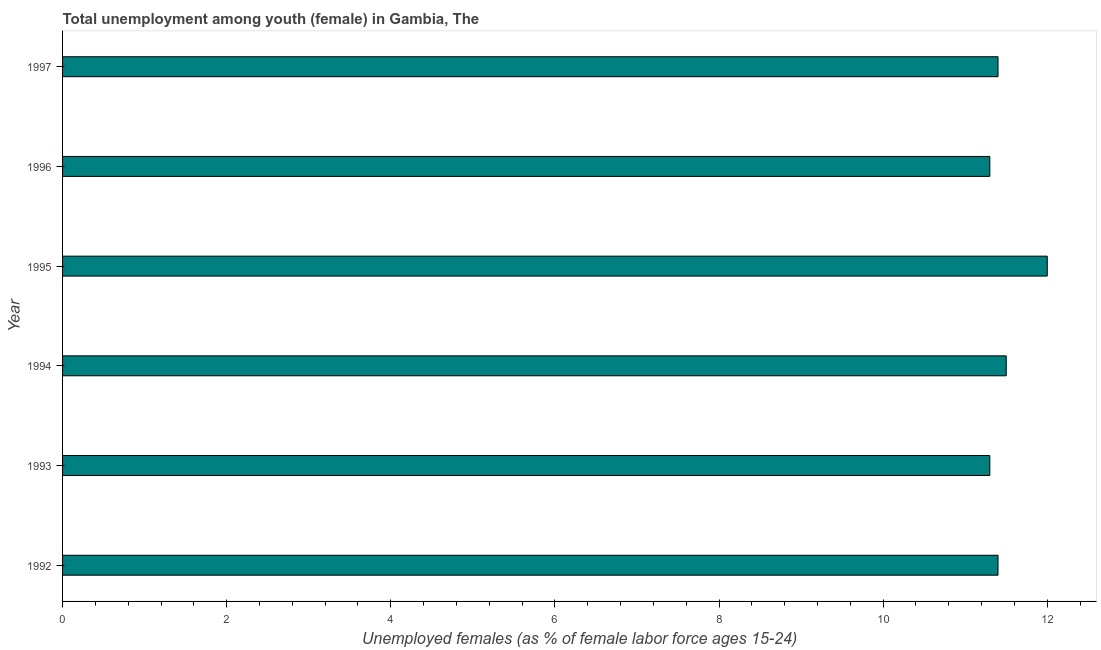Does the graph contain any zero values?
Ensure brevity in your answer.  No. What is the title of the graph?
Your response must be concise. Total unemployment among youth (female) in Gambia, The. What is the label or title of the X-axis?
Keep it short and to the point. Unemployed females (as % of female labor force ages 15-24). What is the label or title of the Y-axis?
Your answer should be compact. Year. What is the unemployed female youth population in 1997?
Your response must be concise. 11.4. Across all years, what is the maximum unemployed female youth population?
Provide a succinct answer. 12. Across all years, what is the minimum unemployed female youth population?
Provide a succinct answer. 11.3. What is the sum of the unemployed female youth population?
Offer a terse response. 68.9. What is the average unemployed female youth population per year?
Your response must be concise. 11.48. What is the median unemployed female youth population?
Your answer should be very brief. 11.4. Do a majority of the years between 1993 and 1997 (inclusive) have unemployed female youth population greater than 9.6 %?
Your answer should be compact. Yes. What is the ratio of the unemployed female youth population in 1992 to that in 1996?
Keep it short and to the point. 1.01. Is the difference between the unemployed female youth population in 1992 and 1996 greater than the difference between any two years?
Provide a short and direct response. No. Is the sum of the unemployed female youth population in 1996 and 1997 greater than the maximum unemployed female youth population across all years?
Your response must be concise. Yes. What is the difference between the highest and the lowest unemployed female youth population?
Provide a short and direct response. 0.7. How many bars are there?
Give a very brief answer. 6. What is the difference between two consecutive major ticks on the X-axis?
Give a very brief answer. 2. What is the Unemployed females (as % of female labor force ages 15-24) of 1992?
Provide a short and direct response. 11.4. What is the Unemployed females (as % of female labor force ages 15-24) of 1993?
Make the answer very short. 11.3. What is the Unemployed females (as % of female labor force ages 15-24) in 1994?
Ensure brevity in your answer.  11.5. What is the Unemployed females (as % of female labor force ages 15-24) in 1995?
Make the answer very short. 12. What is the Unemployed females (as % of female labor force ages 15-24) of 1996?
Provide a succinct answer. 11.3. What is the Unemployed females (as % of female labor force ages 15-24) of 1997?
Keep it short and to the point. 11.4. What is the difference between the Unemployed females (as % of female labor force ages 15-24) in 1992 and 1993?
Give a very brief answer. 0.1. What is the difference between the Unemployed females (as % of female labor force ages 15-24) in 1992 and 1995?
Provide a succinct answer. -0.6. What is the difference between the Unemployed females (as % of female labor force ages 15-24) in 1992 and 1996?
Keep it short and to the point. 0.1. What is the difference between the Unemployed females (as % of female labor force ages 15-24) in 1993 and 1996?
Keep it short and to the point. 0. What is the difference between the Unemployed females (as % of female labor force ages 15-24) in 1995 and 1996?
Offer a terse response. 0.7. What is the difference between the Unemployed females (as % of female labor force ages 15-24) in 1995 and 1997?
Your response must be concise. 0.6. What is the difference between the Unemployed females (as % of female labor force ages 15-24) in 1996 and 1997?
Ensure brevity in your answer.  -0.1. What is the ratio of the Unemployed females (as % of female labor force ages 15-24) in 1992 to that in 1993?
Offer a very short reply. 1.01. What is the ratio of the Unemployed females (as % of female labor force ages 15-24) in 1992 to that in 1995?
Provide a short and direct response. 0.95. What is the ratio of the Unemployed females (as % of female labor force ages 15-24) in 1992 to that in 1996?
Provide a short and direct response. 1.01. What is the ratio of the Unemployed females (as % of female labor force ages 15-24) in 1992 to that in 1997?
Offer a terse response. 1. What is the ratio of the Unemployed females (as % of female labor force ages 15-24) in 1993 to that in 1995?
Your response must be concise. 0.94. What is the ratio of the Unemployed females (as % of female labor force ages 15-24) in 1993 to that in 1997?
Give a very brief answer. 0.99. What is the ratio of the Unemployed females (as % of female labor force ages 15-24) in 1994 to that in 1995?
Make the answer very short. 0.96. What is the ratio of the Unemployed females (as % of female labor force ages 15-24) in 1994 to that in 1997?
Ensure brevity in your answer.  1.01. What is the ratio of the Unemployed females (as % of female labor force ages 15-24) in 1995 to that in 1996?
Make the answer very short. 1.06. What is the ratio of the Unemployed females (as % of female labor force ages 15-24) in 1995 to that in 1997?
Your answer should be very brief. 1.05. 